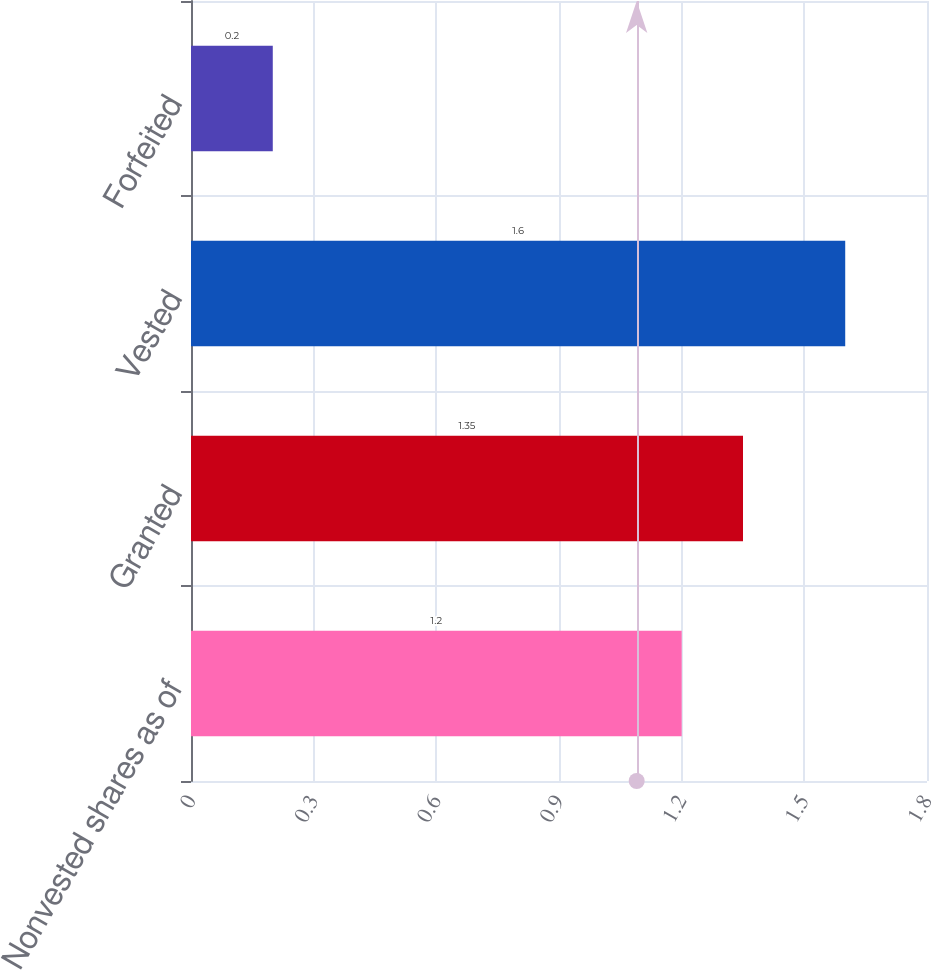Convert chart. <chart><loc_0><loc_0><loc_500><loc_500><bar_chart><fcel>Nonvested shares as of<fcel>Granted<fcel>Vested<fcel>Forfeited<nl><fcel>1.2<fcel>1.35<fcel>1.6<fcel>0.2<nl></chart> 